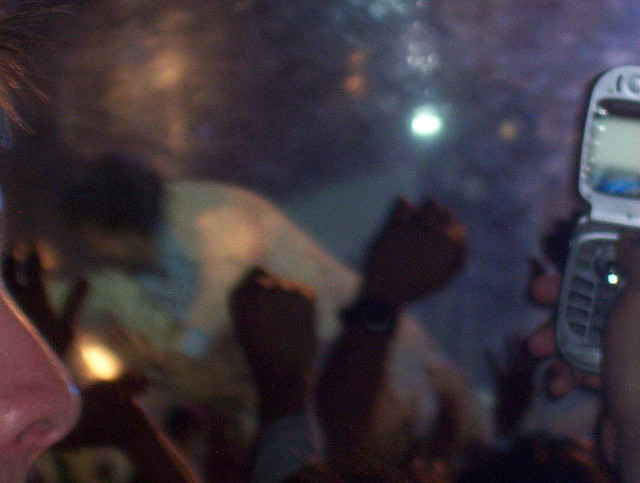<image>What color is the woman's hair? I don't know the color of the woman's hair. It can be seen brown or black. What color is the woman's hair? I am not sure the color of the woman's hair. It can be seen brown, black or no hair. 